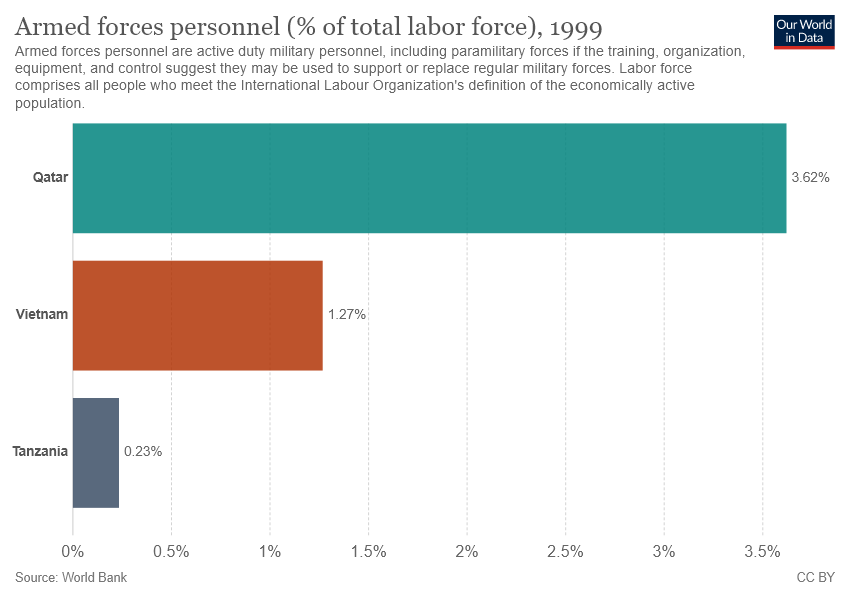Draw attention to some important aspects in this diagram. The value of Qatar is greater than that of Vietnam. Tanzania represents the color gray in the bar. 